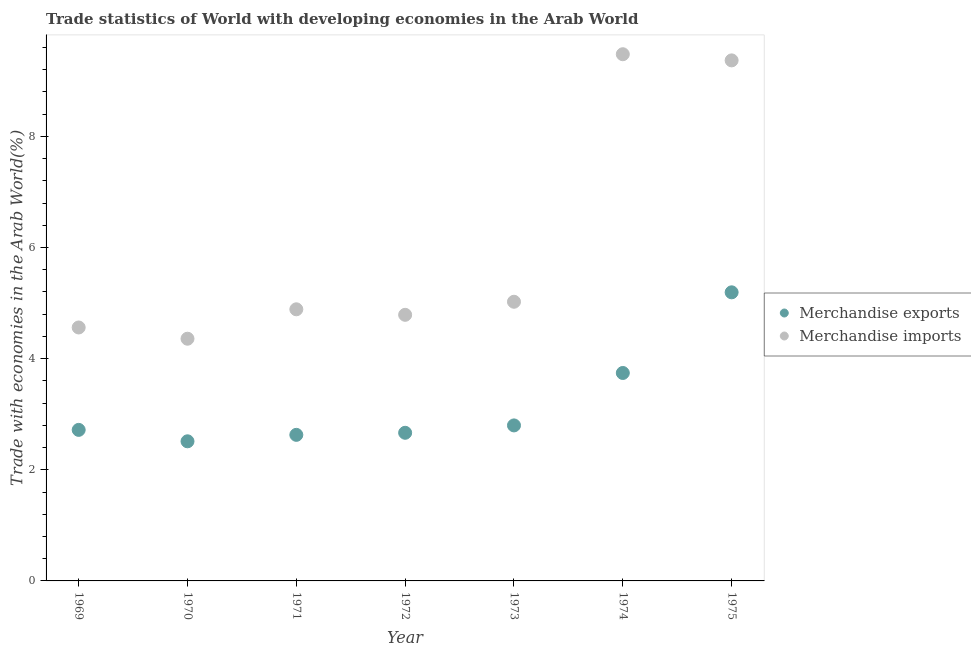How many different coloured dotlines are there?
Offer a terse response. 2. What is the merchandise exports in 1969?
Provide a succinct answer. 2.72. Across all years, what is the maximum merchandise imports?
Your answer should be compact. 9.48. Across all years, what is the minimum merchandise imports?
Your response must be concise. 4.36. In which year was the merchandise exports maximum?
Ensure brevity in your answer.  1975. In which year was the merchandise exports minimum?
Provide a short and direct response. 1970. What is the total merchandise exports in the graph?
Keep it short and to the point. 22.26. What is the difference between the merchandise imports in 1969 and that in 1975?
Offer a very short reply. -4.81. What is the difference between the merchandise imports in 1975 and the merchandise exports in 1974?
Keep it short and to the point. 5.63. What is the average merchandise exports per year?
Provide a succinct answer. 3.18. In the year 1970, what is the difference between the merchandise imports and merchandise exports?
Your answer should be compact. 1.85. In how many years, is the merchandise exports greater than 6.8 %?
Offer a very short reply. 0. What is the ratio of the merchandise exports in 1971 to that in 1974?
Give a very brief answer. 0.7. Is the merchandise exports in 1971 less than that in 1972?
Your response must be concise. Yes. What is the difference between the highest and the second highest merchandise imports?
Your answer should be compact. 0.11. What is the difference between the highest and the lowest merchandise exports?
Your response must be concise. 2.68. In how many years, is the merchandise exports greater than the average merchandise exports taken over all years?
Provide a succinct answer. 2. Is the sum of the merchandise imports in 1969 and 1972 greater than the maximum merchandise exports across all years?
Your response must be concise. Yes. Does the merchandise imports monotonically increase over the years?
Make the answer very short. No. Is the merchandise imports strictly less than the merchandise exports over the years?
Ensure brevity in your answer.  No. How many dotlines are there?
Your answer should be very brief. 2. Where does the legend appear in the graph?
Provide a succinct answer. Center right. How many legend labels are there?
Your response must be concise. 2. What is the title of the graph?
Provide a succinct answer. Trade statistics of World with developing economies in the Arab World. What is the label or title of the Y-axis?
Your response must be concise. Trade with economies in the Arab World(%). What is the Trade with economies in the Arab World(%) in Merchandise exports in 1969?
Offer a terse response. 2.72. What is the Trade with economies in the Arab World(%) in Merchandise imports in 1969?
Keep it short and to the point. 4.56. What is the Trade with economies in the Arab World(%) in Merchandise exports in 1970?
Keep it short and to the point. 2.51. What is the Trade with economies in the Arab World(%) of Merchandise imports in 1970?
Offer a very short reply. 4.36. What is the Trade with economies in the Arab World(%) in Merchandise exports in 1971?
Make the answer very short. 2.63. What is the Trade with economies in the Arab World(%) of Merchandise imports in 1971?
Provide a short and direct response. 4.89. What is the Trade with economies in the Arab World(%) in Merchandise exports in 1972?
Provide a succinct answer. 2.67. What is the Trade with economies in the Arab World(%) in Merchandise imports in 1972?
Your answer should be very brief. 4.79. What is the Trade with economies in the Arab World(%) in Merchandise exports in 1973?
Keep it short and to the point. 2.8. What is the Trade with economies in the Arab World(%) in Merchandise imports in 1973?
Give a very brief answer. 5.02. What is the Trade with economies in the Arab World(%) of Merchandise exports in 1974?
Your answer should be compact. 3.74. What is the Trade with economies in the Arab World(%) in Merchandise imports in 1974?
Provide a succinct answer. 9.48. What is the Trade with economies in the Arab World(%) of Merchandise exports in 1975?
Offer a terse response. 5.19. What is the Trade with economies in the Arab World(%) of Merchandise imports in 1975?
Provide a succinct answer. 9.37. Across all years, what is the maximum Trade with economies in the Arab World(%) of Merchandise exports?
Give a very brief answer. 5.19. Across all years, what is the maximum Trade with economies in the Arab World(%) of Merchandise imports?
Make the answer very short. 9.48. Across all years, what is the minimum Trade with economies in the Arab World(%) of Merchandise exports?
Offer a terse response. 2.51. Across all years, what is the minimum Trade with economies in the Arab World(%) of Merchandise imports?
Offer a very short reply. 4.36. What is the total Trade with economies in the Arab World(%) in Merchandise exports in the graph?
Your response must be concise. 22.26. What is the total Trade with economies in the Arab World(%) in Merchandise imports in the graph?
Your answer should be very brief. 42.47. What is the difference between the Trade with economies in the Arab World(%) in Merchandise exports in 1969 and that in 1970?
Your answer should be compact. 0.21. What is the difference between the Trade with economies in the Arab World(%) of Merchandise imports in 1969 and that in 1970?
Give a very brief answer. 0.2. What is the difference between the Trade with economies in the Arab World(%) of Merchandise exports in 1969 and that in 1971?
Provide a succinct answer. 0.09. What is the difference between the Trade with economies in the Arab World(%) in Merchandise imports in 1969 and that in 1971?
Your answer should be compact. -0.33. What is the difference between the Trade with economies in the Arab World(%) in Merchandise exports in 1969 and that in 1972?
Provide a succinct answer. 0.05. What is the difference between the Trade with economies in the Arab World(%) in Merchandise imports in 1969 and that in 1972?
Ensure brevity in your answer.  -0.23. What is the difference between the Trade with economies in the Arab World(%) of Merchandise exports in 1969 and that in 1973?
Your response must be concise. -0.08. What is the difference between the Trade with economies in the Arab World(%) in Merchandise imports in 1969 and that in 1973?
Offer a very short reply. -0.46. What is the difference between the Trade with economies in the Arab World(%) in Merchandise exports in 1969 and that in 1974?
Provide a succinct answer. -1.02. What is the difference between the Trade with economies in the Arab World(%) of Merchandise imports in 1969 and that in 1974?
Your response must be concise. -4.92. What is the difference between the Trade with economies in the Arab World(%) of Merchandise exports in 1969 and that in 1975?
Ensure brevity in your answer.  -2.48. What is the difference between the Trade with economies in the Arab World(%) in Merchandise imports in 1969 and that in 1975?
Provide a short and direct response. -4.81. What is the difference between the Trade with economies in the Arab World(%) in Merchandise exports in 1970 and that in 1971?
Keep it short and to the point. -0.12. What is the difference between the Trade with economies in the Arab World(%) in Merchandise imports in 1970 and that in 1971?
Provide a succinct answer. -0.53. What is the difference between the Trade with economies in the Arab World(%) of Merchandise exports in 1970 and that in 1972?
Make the answer very short. -0.15. What is the difference between the Trade with economies in the Arab World(%) in Merchandise imports in 1970 and that in 1972?
Give a very brief answer. -0.43. What is the difference between the Trade with economies in the Arab World(%) in Merchandise exports in 1970 and that in 1973?
Offer a very short reply. -0.29. What is the difference between the Trade with economies in the Arab World(%) of Merchandise imports in 1970 and that in 1973?
Make the answer very short. -0.67. What is the difference between the Trade with economies in the Arab World(%) of Merchandise exports in 1970 and that in 1974?
Offer a very short reply. -1.23. What is the difference between the Trade with economies in the Arab World(%) of Merchandise imports in 1970 and that in 1974?
Your answer should be compact. -5.12. What is the difference between the Trade with economies in the Arab World(%) of Merchandise exports in 1970 and that in 1975?
Your response must be concise. -2.68. What is the difference between the Trade with economies in the Arab World(%) in Merchandise imports in 1970 and that in 1975?
Offer a terse response. -5.01. What is the difference between the Trade with economies in the Arab World(%) of Merchandise exports in 1971 and that in 1972?
Offer a terse response. -0.04. What is the difference between the Trade with economies in the Arab World(%) of Merchandise imports in 1971 and that in 1972?
Your response must be concise. 0.1. What is the difference between the Trade with economies in the Arab World(%) of Merchandise exports in 1971 and that in 1973?
Give a very brief answer. -0.17. What is the difference between the Trade with economies in the Arab World(%) of Merchandise imports in 1971 and that in 1973?
Your answer should be very brief. -0.14. What is the difference between the Trade with economies in the Arab World(%) in Merchandise exports in 1971 and that in 1974?
Keep it short and to the point. -1.11. What is the difference between the Trade with economies in the Arab World(%) of Merchandise imports in 1971 and that in 1974?
Offer a terse response. -4.59. What is the difference between the Trade with economies in the Arab World(%) of Merchandise exports in 1971 and that in 1975?
Provide a short and direct response. -2.56. What is the difference between the Trade with economies in the Arab World(%) of Merchandise imports in 1971 and that in 1975?
Your answer should be compact. -4.48. What is the difference between the Trade with economies in the Arab World(%) in Merchandise exports in 1972 and that in 1973?
Offer a very short reply. -0.13. What is the difference between the Trade with economies in the Arab World(%) of Merchandise imports in 1972 and that in 1973?
Make the answer very short. -0.24. What is the difference between the Trade with economies in the Arab World(%) of Merchandise exports in 1972 and that in 1974?
Give a very brief answer. -1.08. What is the difference between the Trade with economies in the Arab World(%) in Merchandise imports in 1972 and that in 1974?
Your answer should be very brief. -4.69. What is the difference between the Trade with economies in the Arab World(%) in Merchandise exports in 1972 and that in 1975?
Give a very brief answer. -2.53. What is the difference between the Trade with economies in the Arab World(%) in Merchandise imports in 1972 and that in 1975?
Give a very brief answer. -4.58. What is the difference between the Trade with economies in the Arab World(%) of Merchandise exports in 1973 and that in 1974?
Ensure brevity in your answer.  -0.94. What is the difference between the Trade with economies in the Arab World(%) in Merchandise imports in 1973 and that in 1974?
Your answer should be compact. -4.45. What is the difference between the Trade with economies in the Arab World(%) in Merchandise exports in 1973 and that in 1975?
Give a very brief answer. -2.4. What is the difference between the Trade with economies in the Arab World(%) of Merchandise imports in 1973 and that in 1975?
Your response must be concise. -4.34. What is the difference between the Trade with economies in the Arab World(%) in Merchandise exports in 1974 and that in 1975?
Your answer should be very brief. -1.45. What is the difference between the Trade with economies in the Arab World(%) of Merchandise imports in 1974 and that in 1975?
Provide a short and direct response. 0.11. What is the difference between the Trade with economies in the Arab World(%) of Merchandise exports in 1969 and the Trade with economies in the Arab World(%) of Merchandise imports in 1970?
Offer a very short reply. -1.64. What is the difference between the Trade with economies in the Arab World(%) of Merchandise exports in 1969 and the Trade with economies in the Arab World(%) of Merchandise imports in 1971?
Offer a terse response. -2.17. What is the difference between the Trade with economies in the Arab World(%) in Merchandise exports in 1969 and the Trade with economies in the Arab World(%) in Merchandise imports in 1972?
Ensure brevity in your answer.  -2.07. What is the difference between the Trade with economies in the Arab World(%) of Merchandise exports in 1969 and the Trade with economies in the Arab World(%) of Merchandise imports in 1973?
Your answer should be compact. -2.31. What is the difference between the Trade with economies in the Arab World(%) in Merchandise exports in 1969 and the Trade with economies in the Arab World(%) in Merchandise imports in 1974?
Your answer should be very brief. -6.76. What is the difference between the Trade with economies in the Arab World(%) in Merchandise exports in 1969 and the Trade with economies in the Arab World(%) in Merchandise imports in 1975?
Offer a terse response. -6.65. What is the difference between the Trade with economies in the Arab World(%) of Merchandise exports in 1970 and the Trade with economies in the Arab World(%) of Merchandise imports in 1971?
Provide a short and direct response. -2.38. What is the difference between the Trade with economies in the Arab World(%) of Merchandise exports in 1970 and the Trade with economies in the Arab World(%) of Merchandise imports in 1972?
Your answer should be compact. -2.28. What is the difference between the Trade with economies in the Arab World(%) in Merchandise exports in 1970 and the Trade with economies in the Arab World(%) in Merchandise imports in 1973?
Ensure brevity in your answer.  -2.51. What is the difference between the Trade with economies in the Arab World(%) in Merchandise exports in 1970 and the Trade with economies in the Arab World(%) in Merchandise imports in 1974?
Offer a very short reply. -6.97. What is the difference between the Trade with economies in the Arab World(%) of Merchandise exports in 1970 and the Trade with economies in the Arab World(%) of Merchandise imports in 1975?
Your answer should be very brief. -6.85. What is the difference between the Trade with economies in the Arab World(%) in Merchandise exports in 1971 and the Trade with economies in the Arab World(%) in Merchandise imports in 1972?
Keep it short and to the point. -2.16. What is the difference between the Trade with economies in the Arab World(%) in Merchandise exports in 1971 and the Trade with economies in the Arab World(%) in Merchandise imports in 1973?
Your response must be concise. -2.4. What is the difference between the Trade with economies in the Arab World(%) in Merchandise exports in 1971 and the Trade with economies in the Arab World(%) in Merchandise imports in 1974?
Offer a terse response. -6.85. What is the difference between the Trade with economies in the Arab World(%) in Merchandise exports in 1971 and the Trade with economies in the Arab World(%) in Merchandise imports in 1975?
Your response must be concise. -6.74. What is the difference between the Trade with economies in the Arab World(%) in Merchandise exports in 1972 and the Trade with economies in the Arab World(%) in Merchandise imports in 1973?
Provide a short and direct response. -2.36. What is the difference between the Trade with economies in the Arab World(%) of Merchandise exports in 1972 and the Trade with economies in the Arab World(%) of Merchandise imports in 1974?
Give a very brief answer. -6.81. What is the difference between the Trade with economies in the Arab World(%) of Merchandise exports in 1972 and the Trade with economies in the Arab World(%) of Merchandise imports in 1975?
Give a very brief answer. -6.7. What is the difference between the Trade with economies in the Arab World(%) in Merchandise exports in 1973 and the Trade with economies in the Arab World(%) in Merchandise imports in 1974?
Your answer should be very brief. -6.68. What is the difference between the Trade with economies in the Arab World(%) in Merchandise exports in 1973 and the Trade with economies in the Arab World(%) in Merchandise imports in 1975?
Offer a very short reply. -6.57. What is the difference between the Trade with economies in the Arab World(%) in Merchandise exports in 1974 and the Trade with economies in the Arab World(%) in Merchandise imports in 1975?
Your answer should be compact. -5.63. What is the average Trade with economies in the Arab World(%) of Merchandise exports per year?
Provide a succinct answer. 3.18. What is the average Trade with economies in the Arab World(%) in Merchandise imports per year?
Your response must be concise. 6.07. In the year 1969, what is the difference between the Trade with economies in the Arab World(%) in Merchandise exports and Trade with economies in the Arab World(%) in Merchandise imports?
Provide a short and direct response. -1.84. In the year 1970, what is the difference between the Trade with economies in the Arab World(%) in Merchandise exports and Trade with economies in the Arab World(%) in Merchandise imports?
Your answer should be very brief. -1.85. In the year 1971, what is the difference between the Trade with economies in the Arab World(%) in Merchandise exports and Trade with economies in the Arab World(%) in Merchandise imports?
Offer a terse response. -2.26. In the year 1972, what is the difference between the Trade with economies in the Arab World(%) of Merchandise exports and Trade with economies in the Arab World(%) of Merchandise imports?
Your response must be concise. -2.12. In the year 1973, what is the difference between the Trade with economies in the Arab World(%) in Merchandise exports and Trade with economies in the Arab World(%) in Merchandise imports?
Offer a terse response. -2.23. In the year 1974, what is the difference between the Trade with economies in the Arab World(%) in Merchandise exports and Trade with economies in the Arab World(%) in Merchandise imports?
Provide a succinct answer. -5.74. In the year 1975, what is the difference between the Trade with economies in the Arab World(%) in Merchandise exports and Trade with economies in the Arab World(%) in Merchandise imports?
Ensure brevity in your answer.  -4.17. What is the ratio of the Trade with economies in the Arab World(%) in Merchandise exports in 1969 to that in 1970?
Ensure brevity in your answer.  1.08. What is the ratio of the Trade with economies in the Arab World(%) in Merchandise imports in 1969 to that in 1970?
Ensure brevity in your answer.  1.05. What is the ratio of the Trade with economies in the Arab World(%) of Merchandise exports in 1969 to that in 1971?
Ensure brevity in your answer.  1.03. What is the ratio of the Trade with economies in the Arab World(%) in Merchandise imports in 1969 to that in 1971?
Ensure brevity in your answer.  0.93. What is the ratio of the Trade with economies in the Arab World(%) in Merchandise exports in 1969 to that in 1972?
Your answer should be very brief. 1.02. What is the ratio of the Trade with economies in the Arab World(%) in Merchandise imports in 1969 to that in 1972?
Offer a very short reply. 0.95. What is the ratio of the Trade with economies in the Arab World(%) in Merchandise exports in 1969 to that in 1973?
Offer a very short reply. 0.97. What is the ratio of the Trade with economies in the Arab World(%) of Merchandise imports in 1969 to that in 1973?
Keep it short and to the point. 0.91. What is the ratio of the Trade with economies in the Arab World(%) in Merchandise exports in 1969 to that in 1974?
Offer a very short reply. 0.73. What is the ratio of the Trade with economies in the Arab World(%) of Merchandise imports in 1969 to that in 1974?
Keep it short and to the point. 0.48. What is the ratio of the Trade with economies in the Arab World(%) in Merchandise exports in 1969 to that in 1975?
Provide a short and direct response. 0.52. What is the ratio of the Trade with economies in the Arab World(%) of Merchandise imports in 1969 to that in 1975?
Offer a terse response. 0.49. What is the ratio of the Trade with economies in the Arab World(%) in Merchandise exports in 1970 to that in 1971?
Offer a very short reply. 0.96. What is the ratio of the Trade with economies in the Arab World(%) of Merchandise imports in 1970 to that in 1971?
Your response must be concise. 0.89. What is the ratio of the Trade with economies in the Arab World(%) in Merchandise exports in 1970 to that in 1972?
Your answer should be very brief. 0.94. What is the ratio of the Trade with economies in the Arab World(%) in Merchandise imports in 1970 to that in 1972?
Your response must be concise. 0.91. What is the ratio of the Trade with economies in the Arab World(%) in Merchandise exports in 1970 to that in 1973?
Make the answer very short. 0.9. What is the ratio of the Trade with economies in the Arab World(%) of Merchandise imports in 1970 to that in 1973?
Provide a short and direct response. 0.87. What is the ratio of the Trade with economies in the Arab World(%) of Merchandise exports in 1970 to that in 1974?
Give a very brief answer. 0.67. What is the ratio of the Trade with economies in the Arab World(%) of Merchandise imports in 1970 to that in 1974?
Provide a succinct answer. 0.46. What is the ratio of the Trade with economies in the Arab World(%) in Merchandise exports in 1970 to that in 1975?
Your response must be concise. 0.48. What is the ratio of the Trade with economies in the Arab World(%) in Merchandise imports in 1970 to that in 1975?
Ensure brevity in your answer.  0.47. What is the ratio of the Trade with economies in the Arab World(%) in Merchandise exports in 1971 to that in 1972?
Offer a terse response. 0.99. What is the ratio of the Trade with economies in the Arab World(%) of Merchandise imports in 1971 to that in 1972?
Keep it short and to the point. 1.02. What is the ratio of the Trade with economies in the Arab World(%) in Merchandise exports in 1971 to that in 1973?
Offer a terse response. 0.94. What is the ratio of the Trade with economies in the Arab World(%) of Merchandise exports in 1971 to that in 1974?
Give a very brief answer. 0.7. What is the ratio of the Trade with economies in the Arab World(%) in Merchandise imports in 1971 to that in 1974?
Your answer should be very brief. 0.52. What is the ratio of the Trade with economies in the Arab World(%) of Merchandise exports in 1971 to that in 1975?
Offer a very short reply. 0.51. What is the ratio of the Trade with economies in the Arab World(%) in Merchandise imports in 1971 to that in 1975?
Offer a very short reply. 0.52. What is the ratio of the Trade with economies in the Arab World(%) in Merchandise exports in 1972 to that in 1973?
Give a very brief answer. 0.95. What is the ratio of the Trade with economies in the Arab World(%) in Merchandise imports in 1972 to that in 1973?
Your answer should be compact. 0.95. What is the ratio of the Trade with economies in the Arab World(%) in Merchandise exports in 1972 to that in 1974?
Offer a very short reply. 0.71. What is the ratio of the Trade with economies in the Arab World(%) in Merchandise imports in 1972 to that in 1974?
Provide a short and direct response. 0.51. What is the ratio of the Trade with economies in the Arab World(%) in Merchandise exports in 1972 to that in 1975?
Your answer should be compact. 0.51. What is the ratio of the Trade with economies in the Arab World(%) in Merchandise imports in 1972 to that in 1975?
Give a very brief answer. 0.51. What is the ratio of the Trade with economies in the Arab World(%) in Merchandise exports in 1973 to that in 1974?
Your answer should be very brief. 0.75. What is the ratio of the Trade with economies in the Arab World(%) of Merchandise imports in 1973 to that in 1974?
Ensure brevity in your answer.  0.53. What is the ratio of the Trade with economies in the Arab World(%) in Merchandise exports in 1973 to that in 1975?
Make the answer very short. 0.54. What is the ratio of the Trade with economies in the Arab World(%) of Merchandise imports in 1973 to that in 1975?
Offer a terse response. 0.54. What is the ratio of the Trade with economies in the Arab World(%) in Merchandise exports in 1974 to that in 1975?
Give a very brief answer. 0.72. What is the ratio of the Trade with economies in the Arab World(%) in Merchandise imports in 1974 to that in 1975?
Offer a very short reply. 1.01. What is the difference between the highest and the second highest Trade with economies in the Arab World(%) of Merchandise exports?
Your answer should be very brief. 1.45. What is the difference between the highest and the second highest Trade with economies in the Arab World(%) in Merchandise imports?
Your answer should be compact. 0.11. What is the difference between the highest and the lowest Trade with economies in the Arab World(%) of Merchandise exports?
Your answer should be compact. 2.68. What is the difference between the highest and the lowest Trade with economies in the Arab World(%) in Merchandise imports?
Provide a short and direct response. 5.12. 